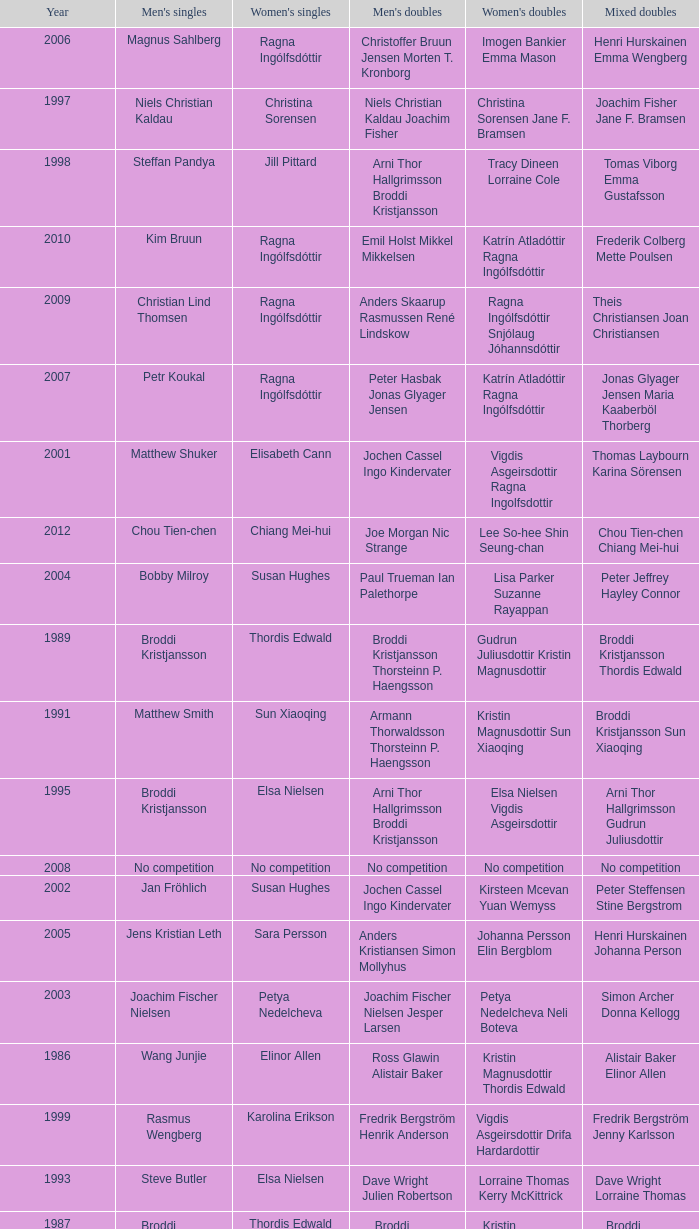Which mixed doubles happened later than 2011? Chou Tien-chen Chiang Mei-hui. Would you be able to parse every entry in this table? {'header': ['Year', "Men's singles", "Women's singles", "Men's doubles", "Women's doubles", 'Mixed doubles'], 'rows': [['2006', 'Magnus Sahlberg', 'Ragna Ingólfsdóttir', 'Christoffer Bruun Jensen Morten T. Kronborg', 'Imogen Bankier Emma Mason', 'Henri Hurskainen Emma Wengberg'], ['1997', 'Niels Christian Kaldau', 'Christina Sorensen', 'Niels Christian Kaldau Joachim Fisher', 'Christina Sorensen Jane F. Bramsen', 'Joachim Fisher Jane F. Bramsen'], ['1998', 'Steffan Pandya', 'Jill Pittard', 'Arni Thor Hallgrimsson Broddi Kristjansson', 'Tracy Dineen Lorraine Cole', 'Tomas Viborg Emma Gustafsson'], ['2010', 'Kim Bruun', 'Ragna Ingólfsdóttir', 'Emil Holst Mikkel Mikkelsen', 'Katrín Atladóttir Ragna Ingólfsdóttir', 'Frederik Colberg Mette Poulsen'], ['2009', 'Christian Lind Thomsen', 'Ragna Ingólfsdóttir', 'Anders Skaarup Rasmussen René Lindskow', 'Ragna Ingólfsdóttir Snjólaug Jóhannsdóttir', 'Theis Christiansen Joan Christiansen'], ['2007', 'Petr Koukal', 'Ragna Ingólfsdóttir', 'Peter Hasbak Jonas Glyager Jensen', 'Katrín Atladóttir Ragna Ingólfsdóttir', 'Jonas Glyager Jensen Maria Kaaberböl Thorberg'], ['2001', 'Matthew Shuker', 'Elisabeth Cann', 'Jochen Cassel Ingo Kindervater', 'Vigdis Asgeirsdottir Ragna Ingolfsdottir', 'Thomas Laybourn Karina Sörensen'], ['2012', 'Chou Tien-chen', 'Chiang Mei-hui', 'Joe Morgan Nic Strange', 'Lee So-hee Shin Seung-chan', 'Chou Tien-chen Chiang Mei-hui'], ['2004', 'Bobby Milroy', 'Susan Hughes', 'Paul Trueman Ian Palethorpe', 'Lisa Parker Suzanne Rayappan', 'Peter Jeffrey Hayley Connor'], ['1989', 'Broddi Kristjansson', 'Thordis Edwald', 'Broddi Kristjansson Thorsteinn P. Haengsson', 'Gudrun Juliusdottir Kristin Magnusdottir', 'Broddi Kristjansson Thordis Edwald'], ['1991', 'Matthew Smith', 'Sun Xiaoqing', 'Armann Thorwaldsson Thorsteinn P. Haengsson', 'Kristin Magnusdottir Sun Xiaoqing', 'Broddi Kristjansson Sun Xiaoqing'], ['1995', 'Broddi Kristjansson', 'Elsa Nielsen', 'Arni Thor Hallgrimsson Broddi Kristjansson', 'Elsa Nielsen Vigdis Asgeirsdottir', 'Arni Thor Hallgrimsson Gudrun Juliusdottir'], ['2008', 'No competition', 'No competition', 'No competition', 'No competition', 'No competition'], ['2002', 'Jan Fröhlich', 'Susan Hughes', 'Jochen Cassel Ingo Kindervater', 'Kirsteen Mcevan Yuan Wemyss', 'Peter Steffensen Stine Bergstrom'], ['2005', 'Jens Kristian Leth', 'Sara Persson', 'Anders Kristiansen Simon Mollyhus', 'Johanna Persson Elin Bergblom', 'Henri Hurskainen Johanna Person'], ['2003', 'Joachim Fischer Nielsen', 'Petya Nedelcheva', 'Joachim Fischer Nielsen Jesper Larsen', 'Petya Nedelcheva Neli Boteva', 'Simon Archer Donna Kellogg'], ['1986', 'Wang Junjie', 'Elinor Allen', 'Ross Glawin Alistair Baker', 'Kristin Magnusdottir Thordis Edwald', 'Alistair Baker Elinor Allen'], ['1999', 'Rasmus Wengberg', 'Karolina Erikson', 'Fredrik Bergström Henrik Anderson', 'Vigdis Asgeirsdottir Drifa Hardardottir', 'Fredrik Bergström Jenny Karlsson'], ['1993', 'Steve Butler', 'Elsa Nielsen', 'Dave Wright Julien Robertson', 'Lorraine Thomas Kerry McKittrick', 'Dave Wright Lorraine Thomas'], ['1987', 'Broddi Kristjansson', 'Thordis Edwald', 'Broddi Kristjansson Thorstein P. Haengsson', 'Kristin Magnusdottir Thordis Edwald', 'Broddi Kristjansson Kristin Magnusdottir'], ['1988', 'Chris Jogis', 'Gudrun Juliusdottir', 'Chris Jogis John Britton', 'Linda French Pam Owens', 'John Britton Pam Owens'], ['2011', 'Mathias Borg', 'Ragna Ingólfsdóttir', 'Thomas Dew-Hattens Mathias Kany', 'Tinna Helgadóttir Snjólaug Jóhannsdóttir', 'Thomas Dew-Hattens Louise Hansen'], ['1994', 'Broddi Kristjansson', 'Elsa Nielsen', 'Arni Thor Hallgrimsson Broddi Kristjansson', 'Birna Petersen Gudrun Juliusdottir', 'Arni Thor Hallgrimsson Gudrun Juliusdottir'], ['1990', 'Broddi Kristjansson', 'Gudrun Juliusdottir', 'Broddi Kristjansson Thorsteinn P. Haengsson', 'Paula Rip Inga Kjartansdottir', 'Thorsteinn P. Haengsson Inga Kjartansdottir'], ['1992', 'Mike Brown', 'Jenny Allen', 'Simon Archer Julia Robertson', 'Jenny Allen Elinor Allen', 'Ken Middlemiss Elinor Allen'], ['2000', 'Colin Haughton', 'Rebecca Pantaney', 'Peter Jeffrey David Lindley', 'Nataly Munt Lisa Parker', 'David Lindley Emma Chraffin'], ['1996', 'Easmus Wengberg', 'Elsa Nielsen', 'Arni Thor Hallgrimsson Broddi Kristjansson', 'Elsa Nielsen Vigdis Asgeirsdottir', 'Arni Thor Hallgrimsson Vigdis Asgeirsdottir']]} 